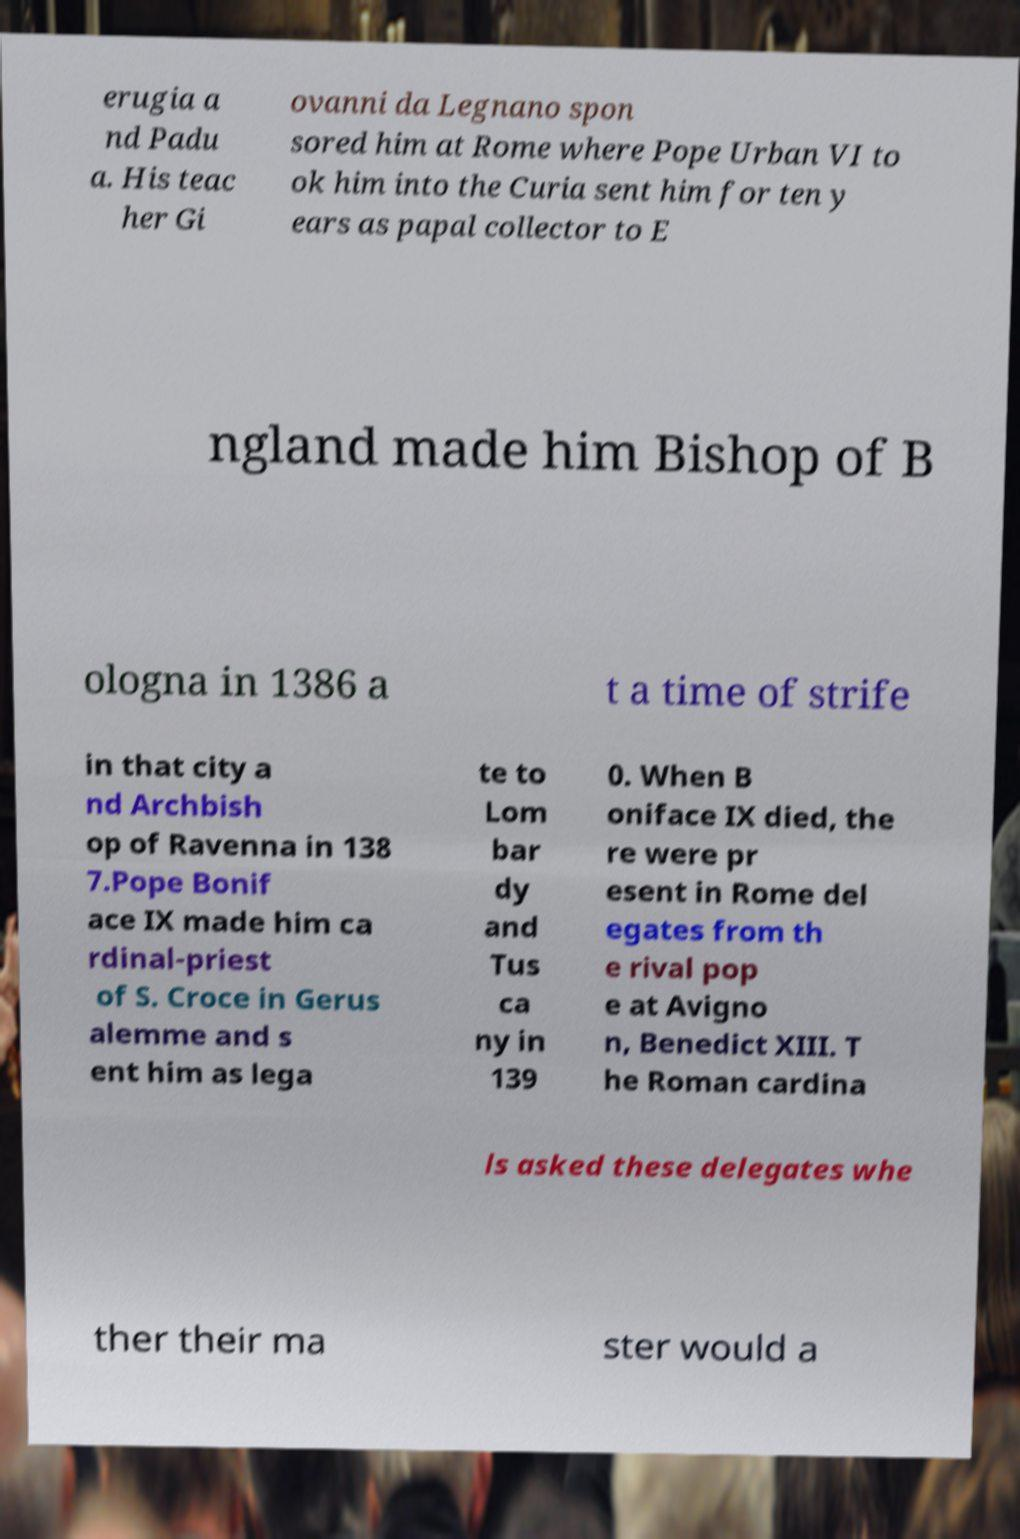What messages or text are displayed in this image? I need them in a readable, typed format. erugia a nd Padu a. His teac her Gi ovanni da Legnano spon sored him at Rome where Pope Urban VI to ok him into the Curia sent him for ten y ears as papal collector to E ngland made him Bishop of B ologna in 1386 a t a time of strife in that city a nd Archbish op of Ravenna in 138 7.Pope Bonif ace IX made him ca rdinal-priest of S. Croce in Gerus alemme and s ent him as lega te to Lom bar dy and Tus ca ny in 139 0. When B oniface IX died, the re were pr esent in Rome del egates from th e rival pop e at Avigno n, Benedict XIII. T he Roman cardina ls asked these delegates whe ther their ma ster would a 